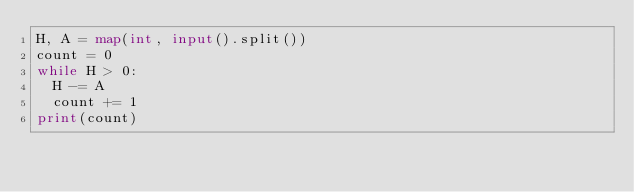Convert code to text. <code><loc_0><loc_0><loc_500><loc_500><_Python_>H, A = map(int, input().split())
count = 0
while H > 0:
  H -= A
  count += 1
print(count)</code> 